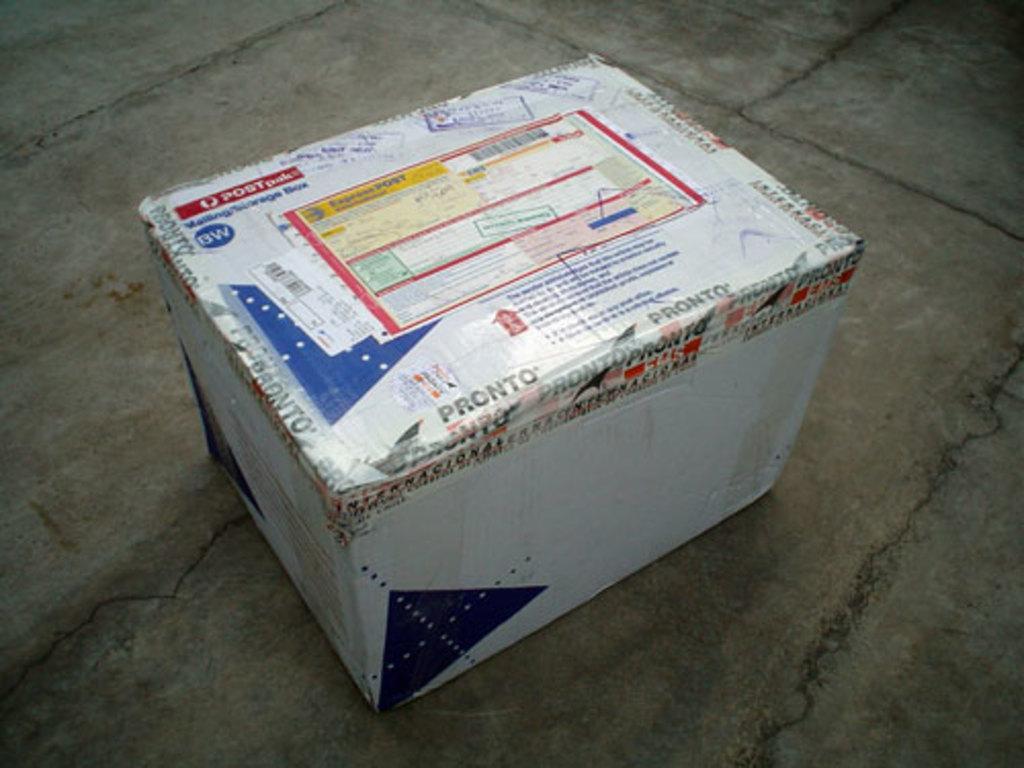Could you give a brief overview of what you see in this image? In this picture there is a cotton box which is kept on the floor. On the box there is a sticker. 